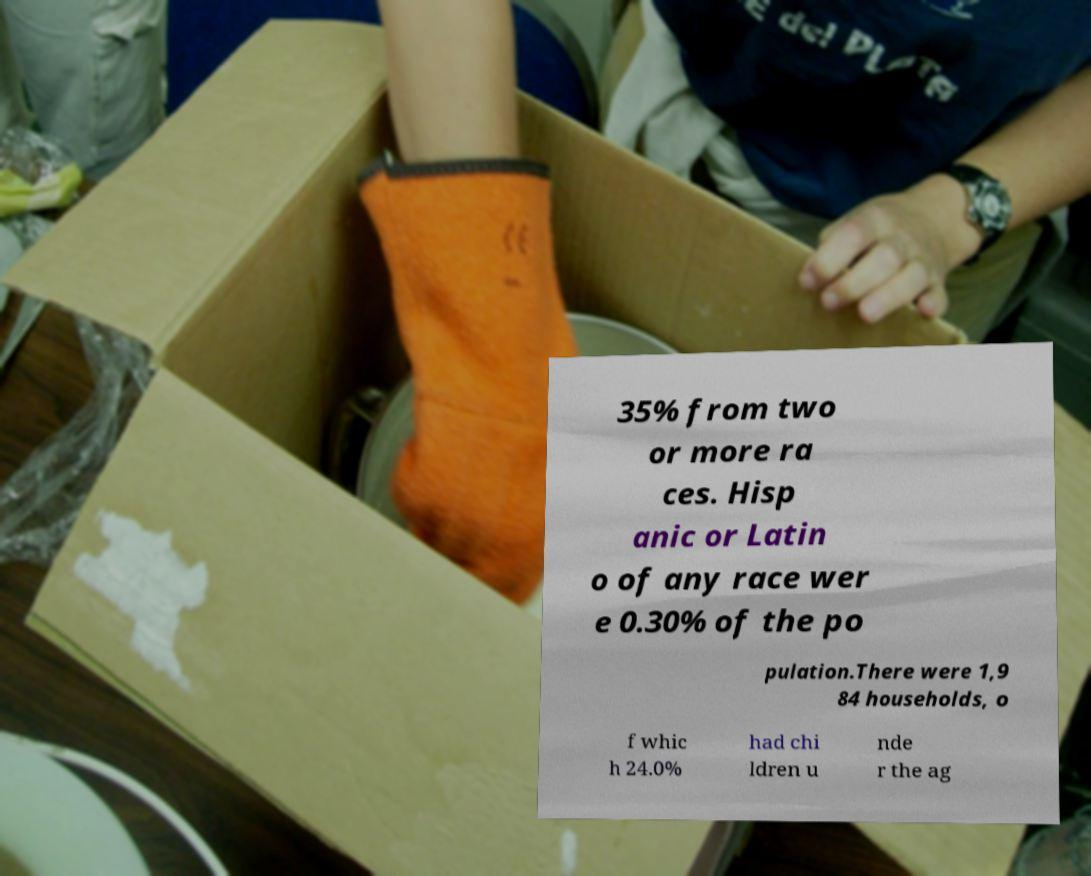Could you assist in decoding the text presented in this image and type it out clearly? 35% from two or more ra ces. Hisp anic or Latin o of any race wer e 0.30% of the po pulation.There were 1,9 84 households, o f whic h 24.0% had chi ldren u nde r the ag 